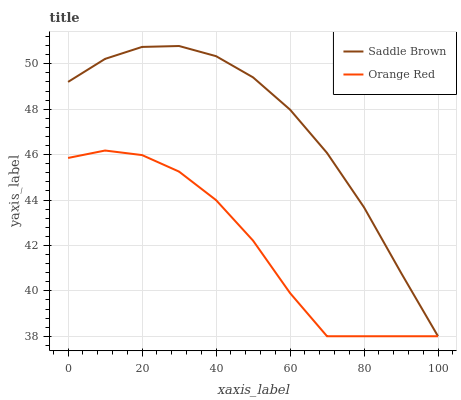Does Orange Red have the maximum area under the curve?
Answer yes or no. No. Is Orange Red the smoothest?
Answer yes or no. No. Does Orange Red have the highest value?
Answer yes or no. No. 